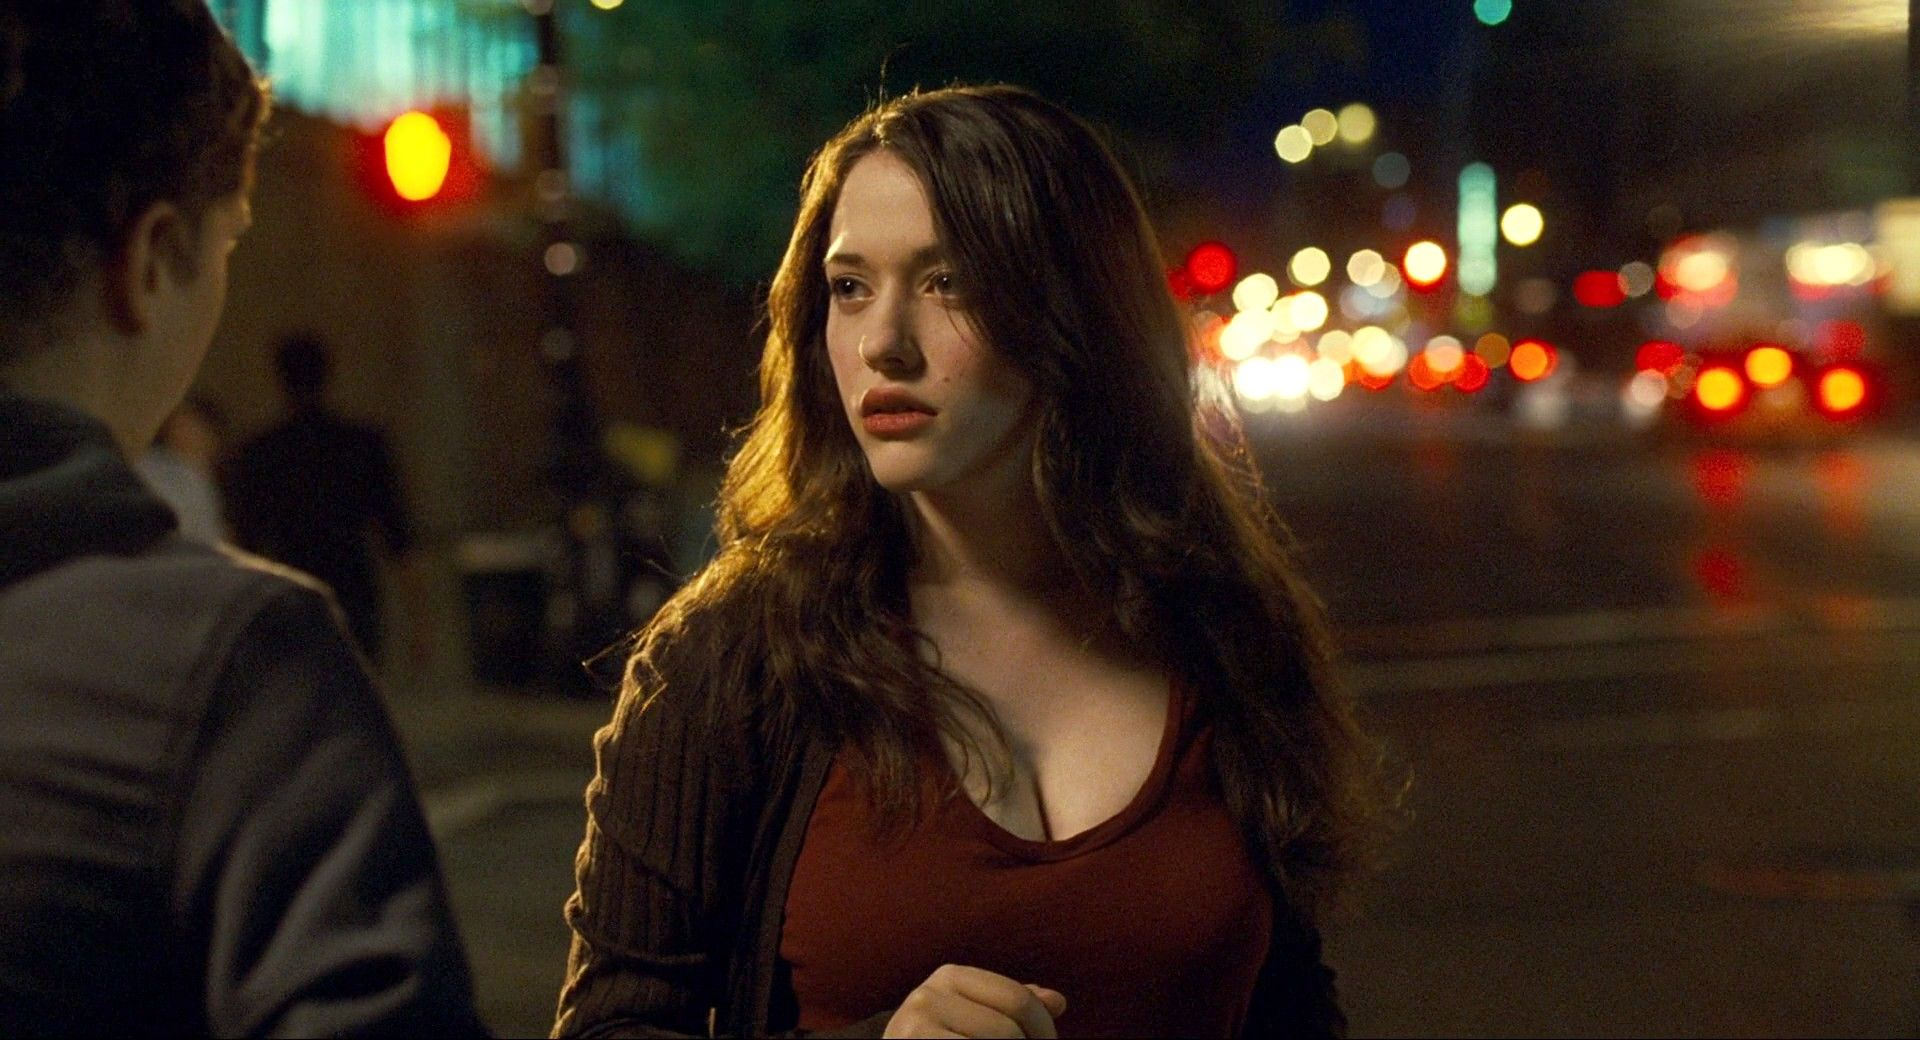Describe the emotional atmosphere of the image. The emotional atmosphere of the image is a blend of solitude and anticipation. The city lights and blurred traffic suggest constant motion and a busy urban life, yet the young woman appears detached from this bustle, caught in a moment of introspection. Her expression and body language hint at a mix of curiosity, contemplation, and possibly longing, creating a rich emotional layer to the urban night setting. 